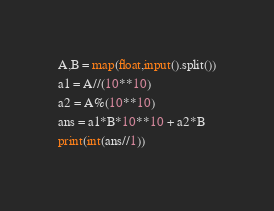Convert code to text. <code><loc_0><loc_0><loc_500><loc_500><_Python_>A,B = map(float,input().split())
a1 = A//(10**10)
a2 = A%(10**10)
ans = a1*B*10**10 + a2*B
print(int(ans//1))</code> 